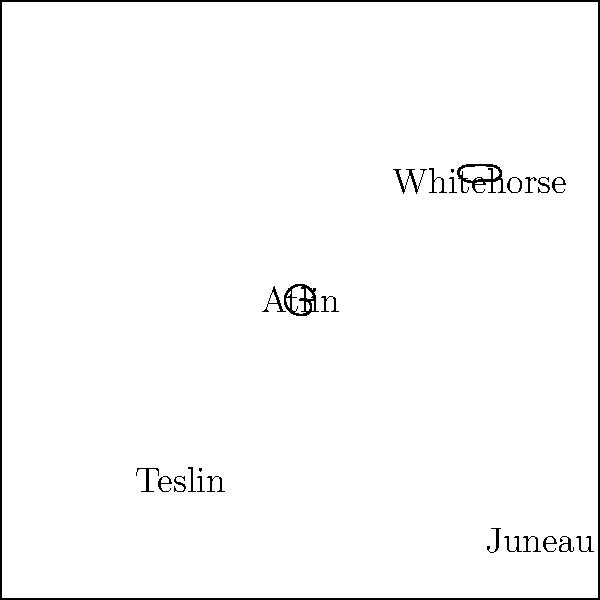Based on the weather forecast map shown, what is the expected temperature in Atlin, and how does it compare to the temperatures in the surrounding areas? To answer this question, let's analyze the weather forecast map step by step:

1. Locate Atlin on the map: Atlin is positioned at the center of the map.

2. Identify the weather symbol for Atlin: There is a sun symbol over Atlin, indicating clear or sunny weather.

3. Find the temperature for Atlin: Next to Atlin, we can see the temperature label "10°C".

4. Compare Atlin's temperature to surrounding areas:
   - Whitehorse: 8°C (cloudy)
   - Teslin: 5°C (cloudy with light rain)
   - Juneau: 7°C (cloudy with rain)

5. Analyze the comparison:
   - Atlin has the highest temperature among all cities shown on the map.
   - Atlin is 2°C warmer than Whitehorse, 5°C warmer than Teslin, and 3°C warmer than Juneau.

Therefore, the expected temperature in Atlin is 10°C, which is warmer than all the surrounding areas shown on the map.
Answer: 10°C, warmest in the region 